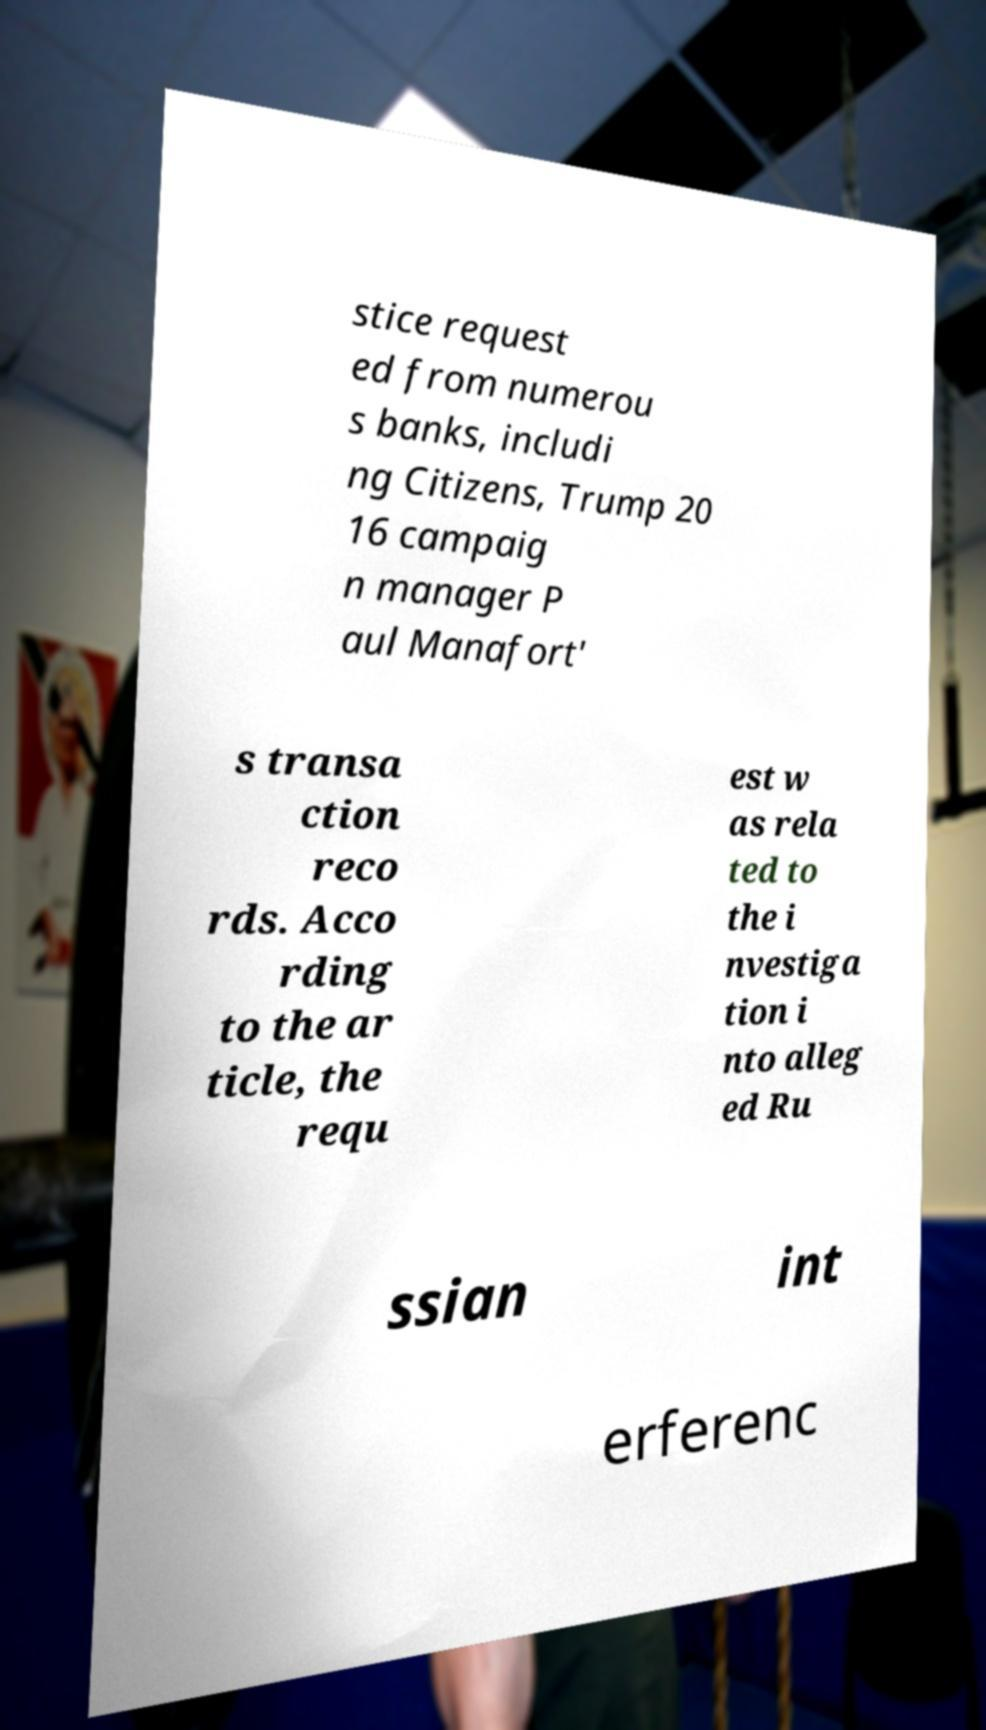Can you read and provide the text displayed in the image?This photo seems to have some interesting text. Can you extract and type it out for me? stice request ed from numerou s banks, includi ng Citizens, Trump 20 16 campaig n manager P aul Manafort' s transa ction reco rds. Acco rding to the ar ticle, the requ est w as rela ted to the i nvestiga tion i nto alleg ed Ru ssian int erferenc 